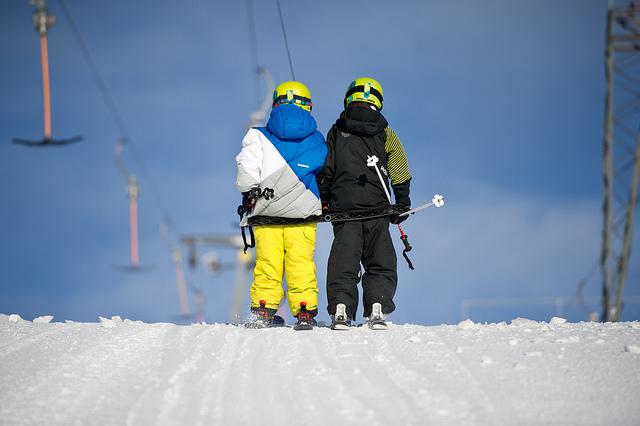Is it winter?
Answer briefly. Yes. What are these people standing on?
Be succinct. Snow. What is in the air on the left?
Short answer required. Ski lift. 